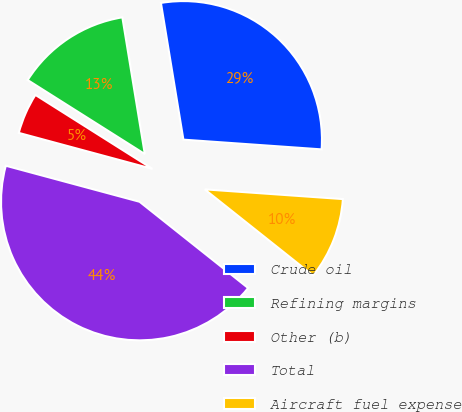Convert chart to OTSL. <chart><loc_0><loc_0><loc_500><loc_500><pie_chart><fcel>Crude oil<fcel>Refining margins<fcel>Other (b)<fcel>Total<fcel>Aircraft fuel expense<nl><fcel>28.71%<fcel>13.44%<fcel>4.78%<fcel>43.5%<fcel>9.57%<nl></chart> 